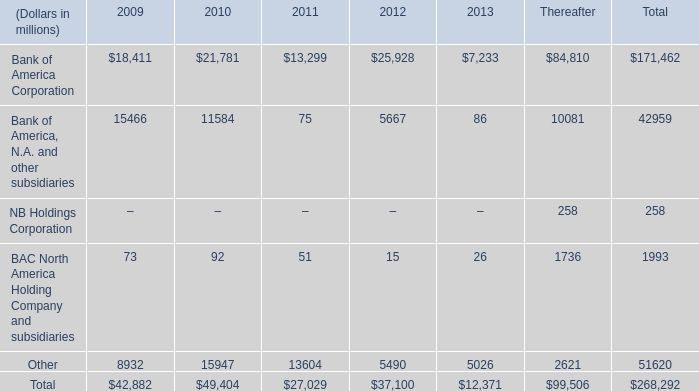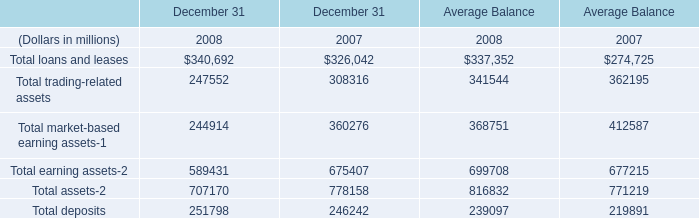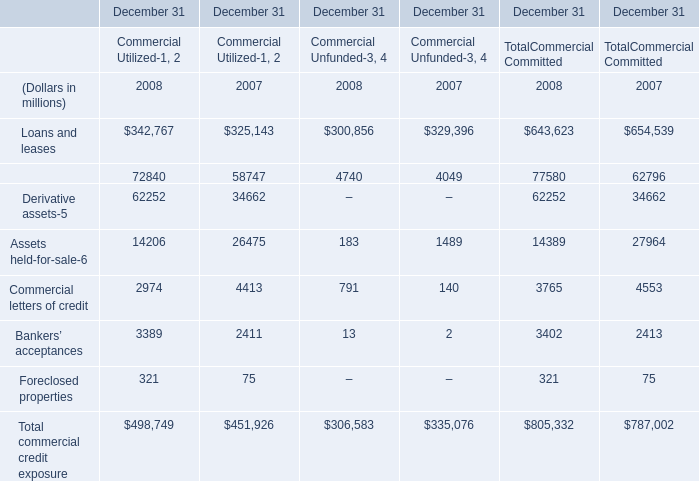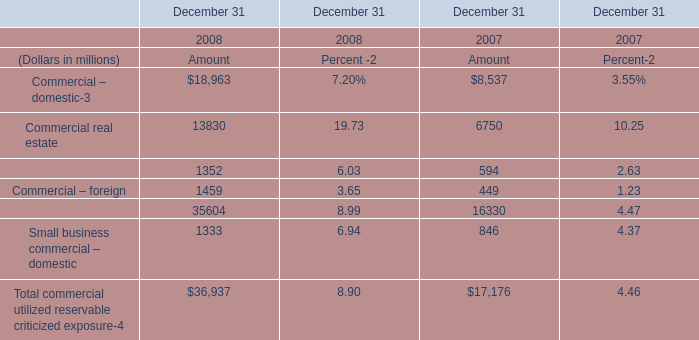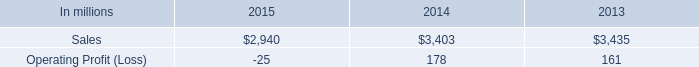If small business commercial – domestic develops with the same growth rate in 2008, what will it reach in 2009? (in dollars in millions) 
Computations: (1333 * (1 + ((1333 - 846) / 846)))
Answer: 2100.34161. 